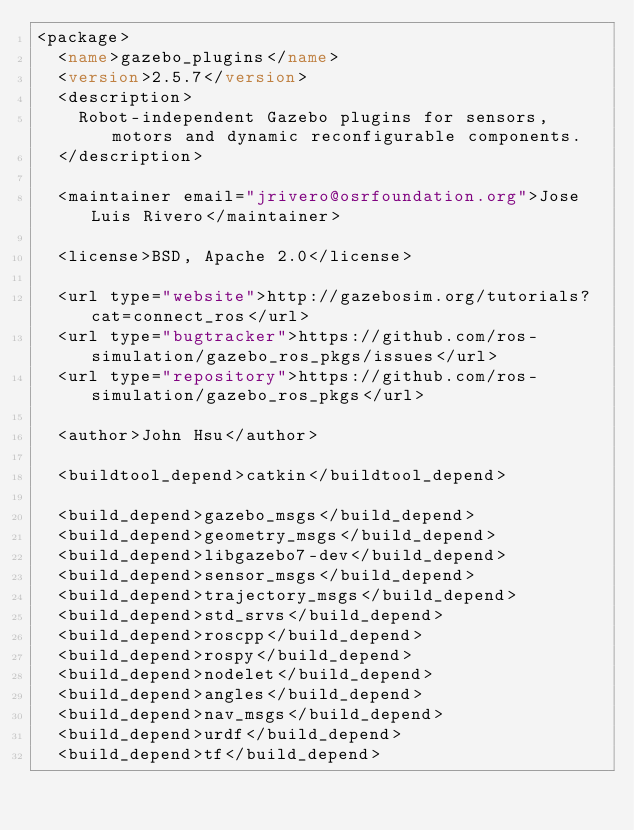<code> <loc_0><loc_0><loc_500><loc_500><_XML_><package>
  <name>gazebo_plugins</name>
  <version>2.5.7</version>
  <description>
    Robot-independent Gazebo plugins for sensors, motors and dynamic reconfigurable components.
  </description>

  <maintainer email="jrivero@osrfoundation.org">Jose Luis Rivero</maintainer>

  <license>BSD, Apache 2.0</license>

  <url type="website">http://gazebosim.org/tutorials?cat=connect_ros</url>
  <url type="bugtracker">https://github.com/ros-simulation/gazebo_ros_pkgs/issues</url>
  <url type="repository">https://github.com/ros-simulation/gazebo_ros_pkgs</url>

  <author>John Hsu</author>

  <buildtool_depend>catkin</buildtool_depend>

  <build_depend>gazebo_msgs</build_depend>
  <build_depend>geometry_msgs</build_depend>
  <build_depend>libgazebo7-dev</build_depend>
  <build_depend>sensor_msgs</build_depend>
  <build_depend>trajectory_msgs</build_depend>
  <build_depend>std_srvs</build_depend>
  <build_depend>roscpp</build_depend>
  <build_depend>rospy</build_depend>
  <build_depend>nodelet</build_depend>
  <build_depend>angles</build_depend>
  <build_depend>nav_msgs</build_depend>
  <build_depend>urdf</build_depend>
  <build_depend>tf</build_depend></code> 